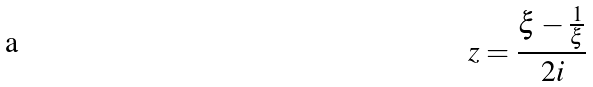<formula> <loc_0><loc_0><loc_500><loc_500>z = \frac { \xi - \frac { 1 } { \xi } } { 2 i }</formula> 